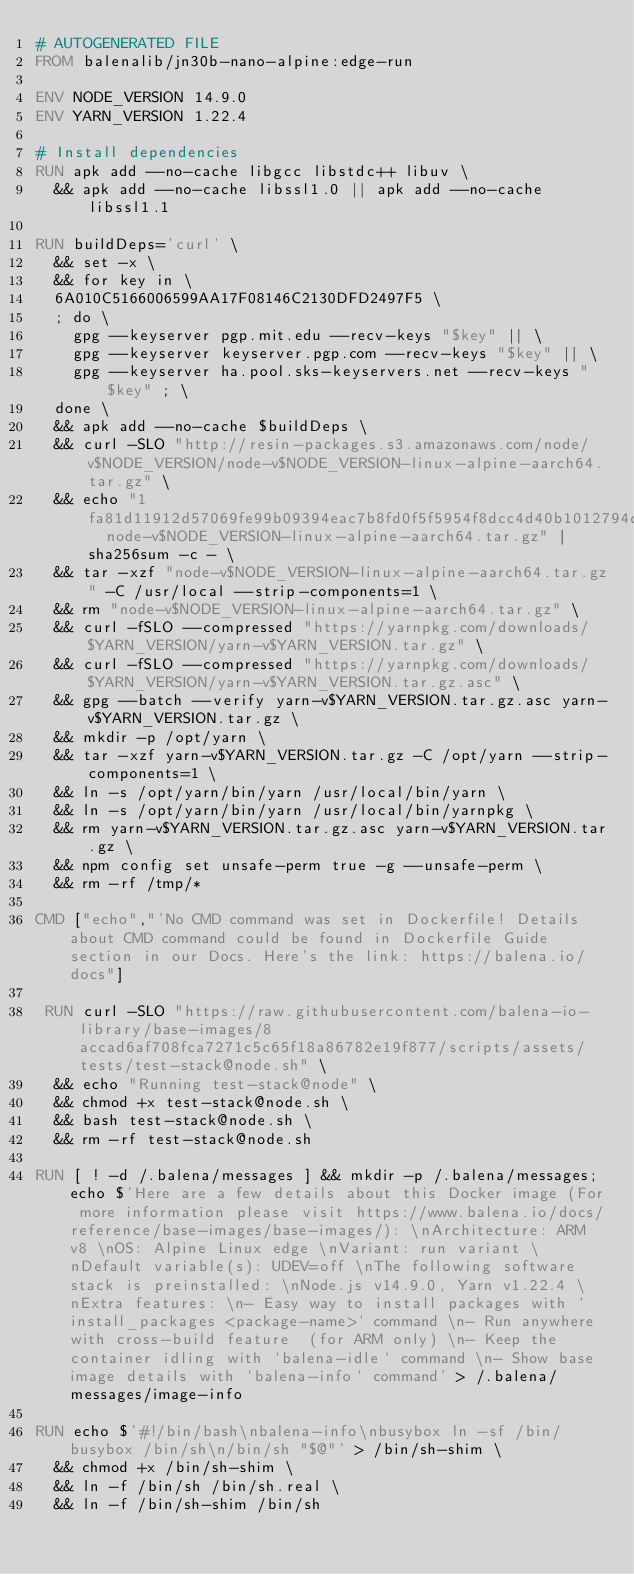Convert code to text. <code><loc_0><loc_0><loc_500><loc_500><_Dockerfile_># AUTOGENERATED FILE
FROM balenalib/jn30b-nano-alpine:edge-run

ENV NODE_VERSION 14.9.0
ENV YARN_VERSION 1.22.4

# Install dependencies
RUN apk add --no-cache libgcc libstdc++ libuv \
	&& apk add --no-cache libssl1.0 || apk add --no-cache libssl1.1

RUN buildDeps='curl' \
	&& set -x \
	&& for key in \
	6A010C5166006599AA17F08146C2130DFD2497F5 \
	; do \
		gpg --keyserver pgp.mit.edu --recv-keys "$key" || \
		gpg --keyserver keyserver.pgp.com --recv-keys "$key" || \
		gpg --keyserver ha.pool.sks-keyservers.net --recv-keys "$key" ; \
	done \
	&& apk add --no-cache $buildDeps \
	&& curl -SLO "http://resin-packages.s3.amazonaws.com/node/v$NODE_VERSION/node-v$NODE_VERSION-linux-alpine-aarch64.tar.gz" \
	&& echo "1fa81d11912d57069fe99b09394eac7b8fd0f5f5954f8dcc4d40b1012794de0b  node-v$NODE_VERSION-linux-alpine-aarch64.tar.gz" | sha256sum -c - \
	&& tar -xzf "node-v$NODE_VERSION-linux-alpine-aarch64.tar.gz" -C /usr/local --strip-components=1 \
	&& rm "node-v$NODE_VERSION-linux-alpine-aarch64.tar.gz" \
	&& curl -fSLO --compressed "https://yarnpkg.com/downloads/$YARN_VERSION/yarn-v$YARN_VERSION.tar.gz" \
	&& curl -fSLO --compressed "https://yarnpkg.com/downloads/$YARN_VERSION/yarn-v$YARN_VERSION.tar.gz.asc" \
	&& gpg --batch --verify yarn-v$YARN_VERSION.tar.gz.asc yarn-v$YARN_VERSION.tar.gz \
	&& mkdir -p /opt/yarn \
	&& tar -xzf yarn-v$YARN_VERSION.tar.gz -C /opt/yarn --strip-components=1 \
	&& ln -s /opt/yarn/bin/yarn /usr/local/bin/yarn \
	&& ln -s /opt/yarn/bin/yarn /usr/local/bin/yarnpkg \
	&& rm yarn-v$YARN_VERSION.tar.gz.asc yarn-v$YARN_VERSION.tar.gz \
	&& npm config set unsafe-perm true -g --unsafe-perm \
	&& rm -rf /tmp/*

CMD ["echo","'No CMD command was set in Dockerfile! Details about CMD command could be found in Dockerfile Guide section in our Docs. Here's the link: https://balena.io/docs"]

 RUN curl -SLO "https://raw.githubusercontent.com/balena-io-library/base-images/8accad6af708fca7271c5c65f18a86782e19f877/scripts/assets/tests/test-stack@node.sh" \
  && echo "Running test-stack@node" \
  && chmod +x test-stack@node.sh \
  && bash test-stack@node.sh \
  && rm -rf test-stack@node.sh 

RUN [ ! -d /.balena/messages ] && mkdir -p /.balena/messages; echo $'Here are a few details about this Docker image (For more information please visit https://www.balena.io/docs/reference/base-images/base-images/): \nArchitecture: ARM v8 \nOS: Alpine Linux edge \nVariant: run variant \nDefault variable(s): UDEV=off \nThe following software stack is preinstalled: \nNode.js v14.9.0, Yarn v1.22.4 \nExtra features: \n- Easy way to install packages with `install_packages <package-name>` command \n- Run anywhere with cross-build feature  (for ARM only) \n- Keep the container idling with `balena-idle` command \n- Show base image details with `balena-info` command' > /.balena/messages/image-info

RUN echo $'#!/bin/bash\nbalena-info\nbusybox ln -sf /bin/busybox /bin/sh\n/bin/sh "$@"' > /bin/sh-shim \
	&& chmod +x /bin/sh-shim \
	&& ln -f /bin/sh /bin/sh.real \
	&& ln -f /bin/sh-shim /bin/sh</code> 